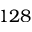Convert formula to latex. <formula><loc_0><loc_0><loc_500><loc_500>1 2 8</formula> 